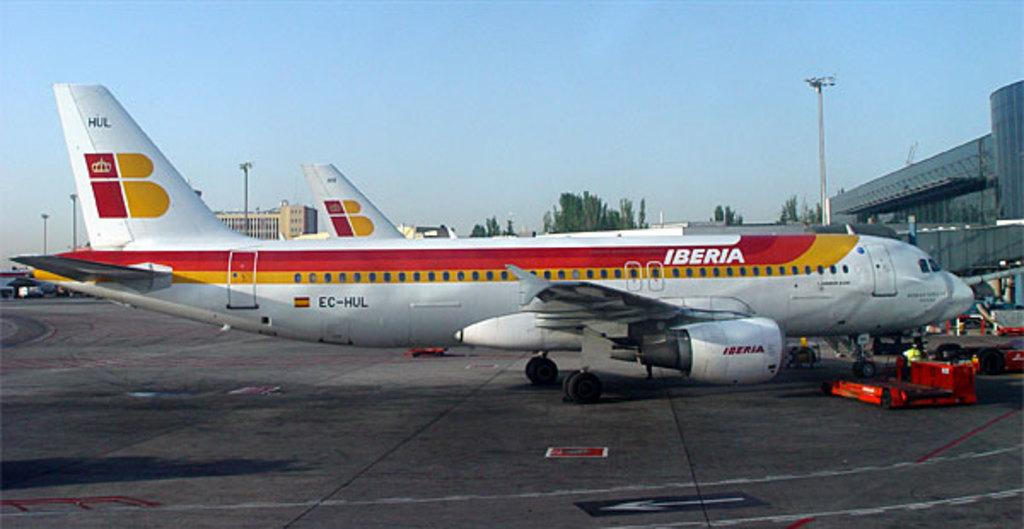<image>
Offer a succinct explanation of the picture presented. A plane belongin to Iberia at an airport  terminal. 